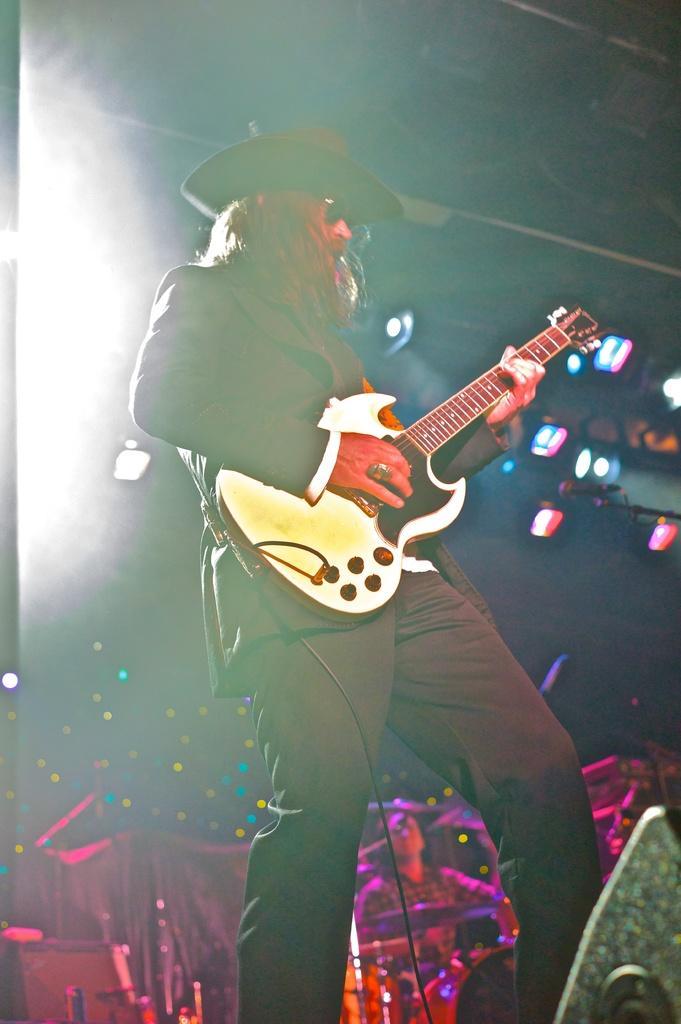In one or two sentences, can you explain what this image depicts? A man standing in the front is wearing a black dress and a black cap and is playing electrical guitar. He also wore shades and a finger ring. There is also another man in the background playing drums. In the background there is a microphone, a curtain decorated with lights. 